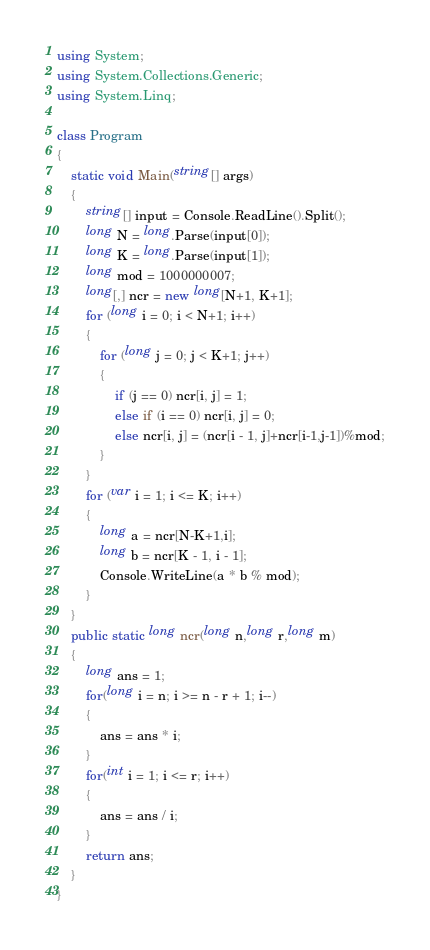<code> <loc_0><loc_0><loc_500><loc_500><_C#_>using System;
using System.Collections.Generic;
using System.Linq;

class Program
{
    static void Main(string[] args)
    {
        string[] input = Console.ReadLine().Split();
        long N = long.Parse(input[0]);
        long K = long.Parse(input[1]);
        long mod = 1000000007;
        long[,] ncr = new long[N+1, K+1];
        for (long i = 0; i < N+1; i++)
        {
            for (long j = 0; j < K+1; j++)
            {
                if (j == 0) ncr[i, j] = 1;
                else if (i == 0) ncr[i, j] = 0;
                else ncr[i, j] = (ncr[i - 1, j]+ncr[i-1,j-1])%mod;
            }
        }
        for (var i = 1; i <= K; i++)
        {
            long a = ncr[N-K+1,i];
            long b = ncr[K - 1, i - 1];
            Console.WriteLine(a * b % mod);
        }
    }
    public static long ncr(long n,long r,long m)
    {
        long ans = 1;
        for(long i = n; i >= n - r + 1; i--)
        {
            ans = ans * i;
        }
        for(int i = 1; i <= r; i++)
        {
            ans = ans / i;
        }
        return ans;
    }
}
</code> 